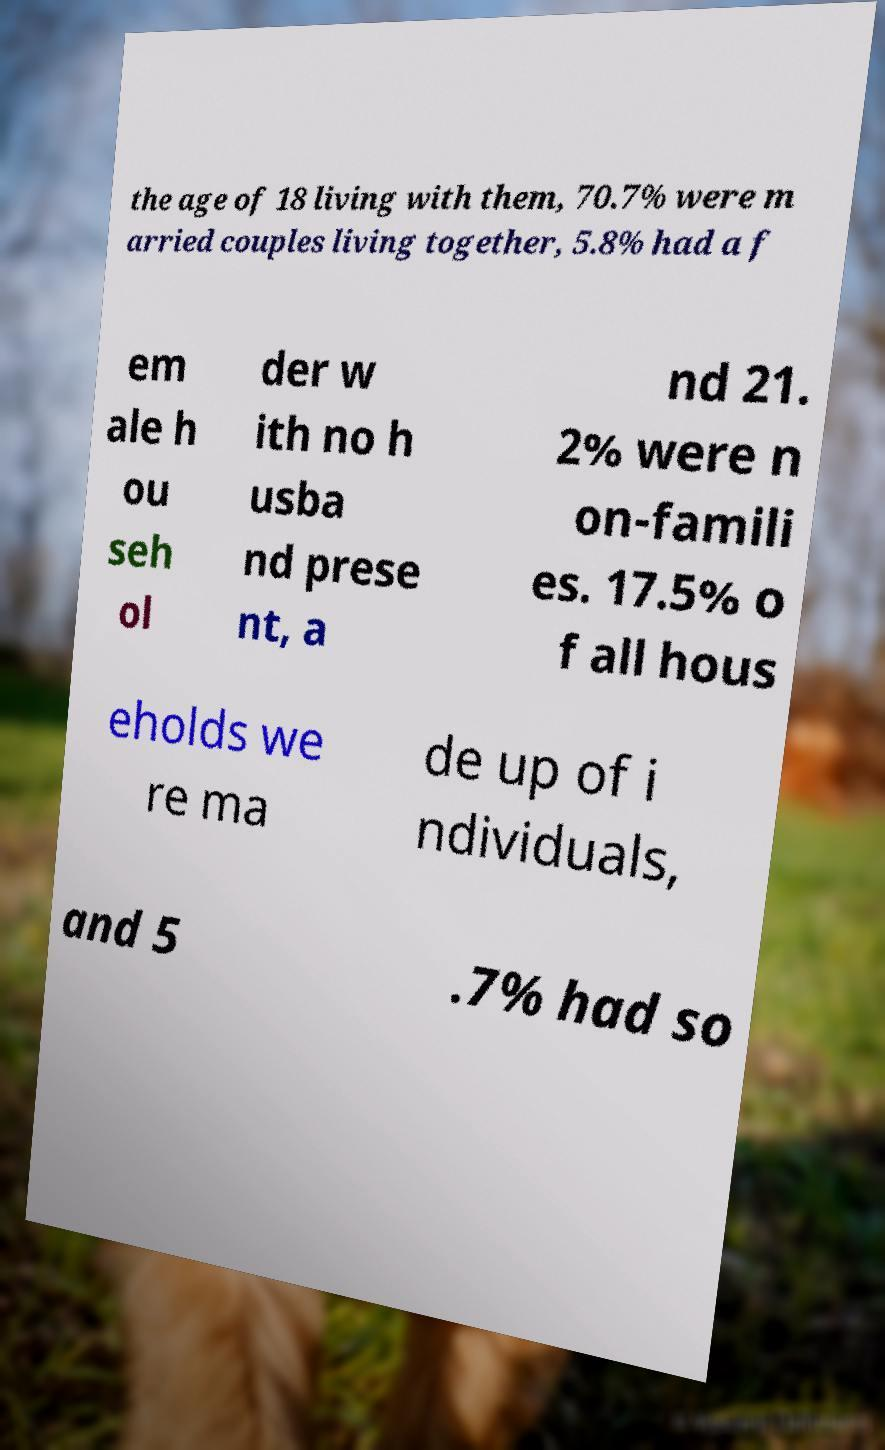Could you extract and type out the text from this image? the age of 18 living with them, 70.7% were m arried couples living together, 5.8% had a f em ale h ou seh ol der w ith no h usba nd prese nt, a nd 21. 2% were n on-famili es. 17.5% o f all hous eholds we re ma de up of i ndividuals, and 5 .7% had so 